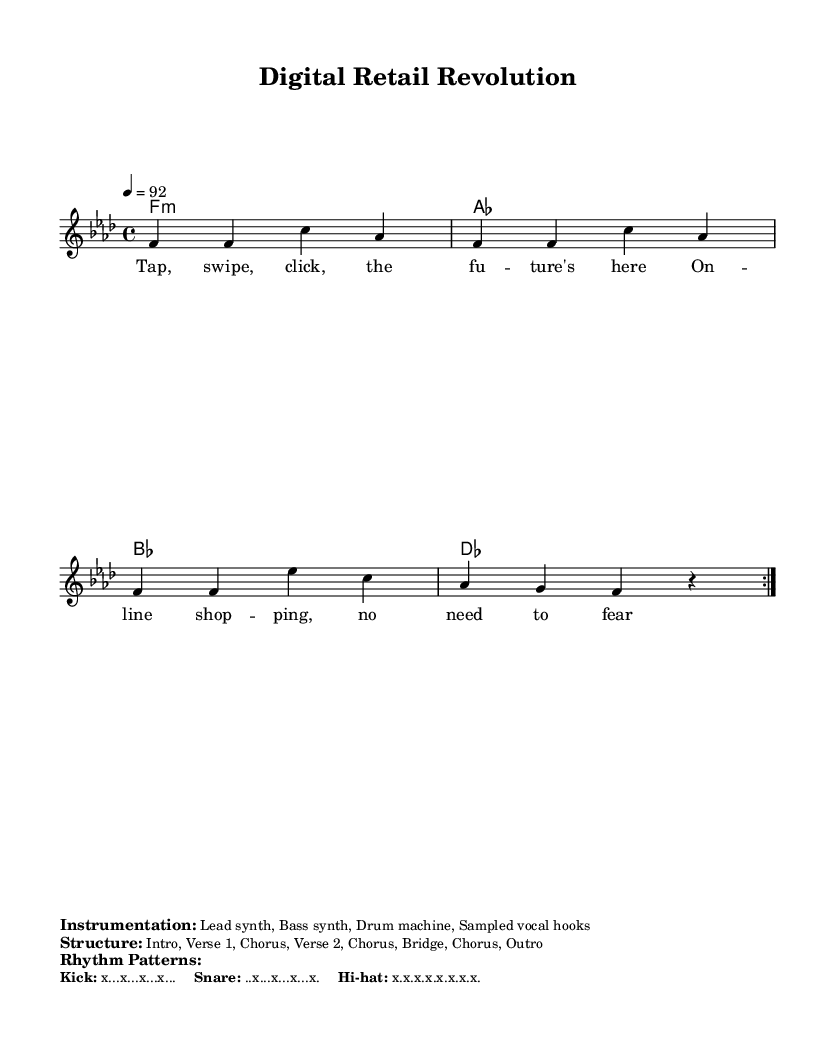What is the key signature of this music? The key signature is indicated at the beginning of the piece and shows two flats, indicating F minor.
Answer: F minor What is the time signature of the piece? The time signature is found next to the clef at the beginning and indicates that there are four beats in each measure.
Answer: 4/4 What is the tempo marking for the song? The tempo marking shows that the piece should be played at a speed of 92 beats per minute, which is indicated as "4 = 92."
Answer: 92 What are the first two words of the lyrics? The lyrics begin with the words "Tap, swipe," which are the first words listed under the melody section.
Answer: Tap, swipe How many main sections are in the song structure? The structure of the song consists of multiple sections, specifically mentioned as "Intro, Verse 1, Chorus, Verse 2, Chorus, Bridge, Chorus, Outro," which indicates a total of 8 main sections.
Answer: 8 What types of instruments are listed in the instrumentation? The instrumentation section names the specific types of instruments used, which are "Lead synth, Bass synth, Drum machine, Sampled vocal hooks."
Answer: Lead synth, Bass synth, Drum machine, Sampled vocal hooks 